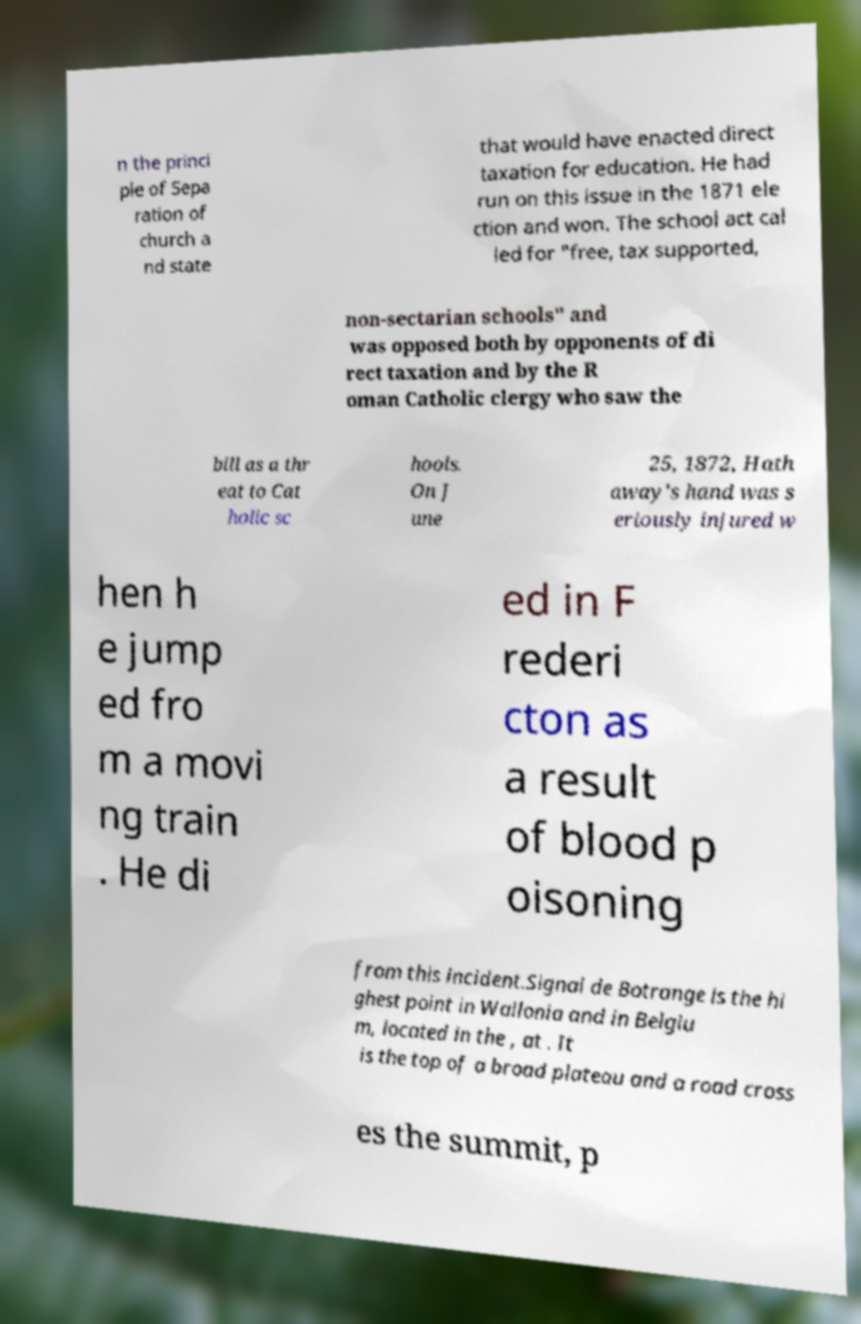Please identify and transcribe the text found in this image. n the princi ple of Sepa ration of church a nd state that would have enacted direct taxation for education. He had run on this issue in the 1871 ele ction and won. The school act cal led for "free, tax supported, non-sectarian schools" and was opposed both by opponents of di rect taxation and by the R oman Catholic clergy who saw the bill as a thr eat to Cat holic sc hools. On J une 25, 1872, Hath away's hand was s eriously injured w hen h e jump ed fro m a movi ng train . He di ed in F rederi cton as a result of blood p oisoning from this incident.Signal de Botrange is the hi ghest point in Wallonia and in Belgiu m, located in the , at . It is the top of a broad plateau and a road cross es the summit, p 